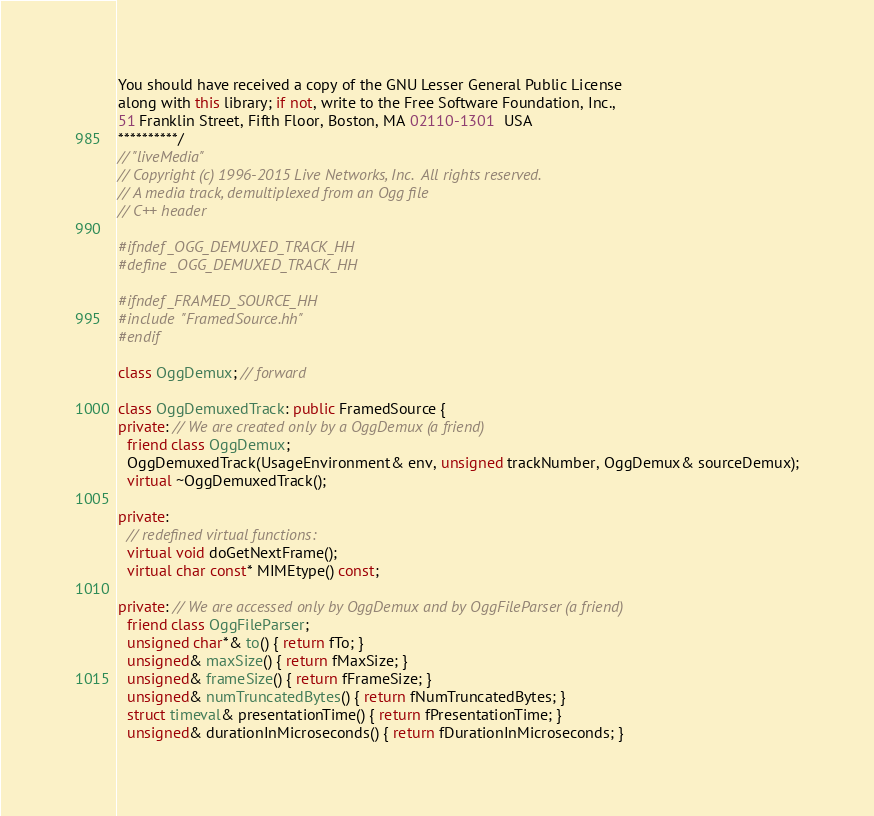<code> <loc_0><loc_0><loc_500><loc_500><_C++_>You should have received a copy of the GNU Lesser General Public License
along with this library; if not, write to the Free Software Foundation, Inc.,
51 Franklin Street, Fifth Floor, Boston, MA 02110-1301  USA
**********/
// "liveMedia"
// Copyright (c) 1996-2015 Live Networks, Inc.  All rights reserved.
// A media track, demultiplexed from an Ogg file
// C++ header

#ifndef _OGG_DEMUXED_TRACK_HH
#define _OGG_DEMUXED_TRACK_HH

#ifndef _FRAMED_SOURCE_HH
#include "FramedSource.hh"
#endif

class OggDemux; // forward

class OggDemuxedTrack: public FramedSource {
private: // We are created only by a OggDemux (a friend)
  friend class OggDemux;
  OggDemuxedTrack(UsageEnvironment& env, unsigned trackNumber, OggDemux& sourceDemux);
  virtual ~OggDemuxedTrack();

private:
  // redefined virtual functions:
  virtual void doGetNextFrame();
  virtual char const* MIMEtype() const;

private: // We are accessed only by OggDemux and by OggFileParser (a friend)
  friend class OggFileParser;
  unsigned char*& to() { return fTo; }
  unsigned& maxSize() { return fMaxSize; }
  unsigned& frameSize() { return fFrameSize; }
  unsigned& numTruncatedBytes() { return fNumTruncatedBytes; }
  struct timeval& presentationTime() { return fPresentationTime; }
  unsigned& durationInMicroseconds() { return fDurationInMicroseconds; }</code> 